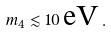Convert formula to latex. <formula><loc_0><loc_0><loc_500><loc_500>m _ { 4 } \lesssim 1 0 \, \text {eV} \, .</formula> 